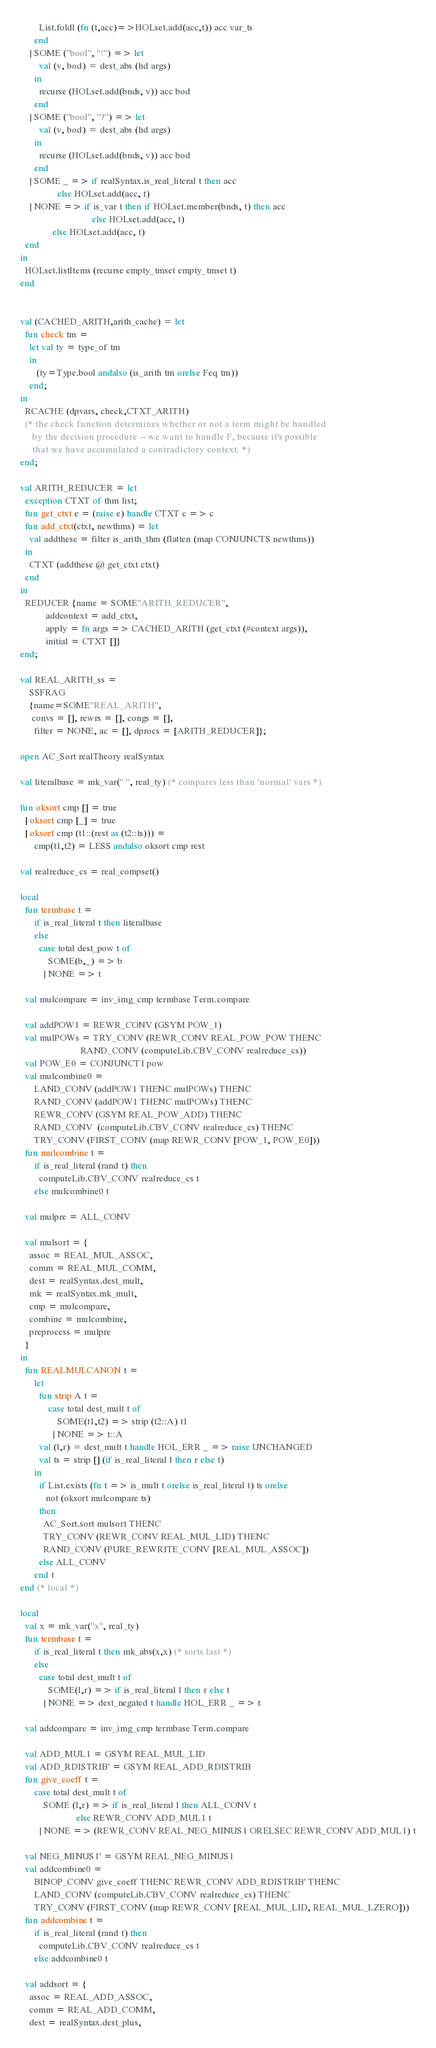<code> <loc_0><loc_0><loc_500><loc_500><_SML_>        List.foldl (fn (t,acc)=>HOLset.add(acc,t)) acc var_ts
      end
    | SOME ("bool", "!") => let
        val (v, bod) = dest_abs (hd args)
      in
        recurse (HOLset.add(bnds, v)) acc bod
      end
    | SOME ("bool", "?") => let
        val (v, bod) = dest_abs (hd args)
      in
        recurse (HOLset.add(bnds, v)) acc bod
      end
    | SOME _ => if realSyntax.is_real_literal t then acc
                else HOLset.add(acc, t)
    | NONE => if is_var t then if HOLset.member(bnds, t) then acc
                               else HOLset.add(acc, t)
              else HOLset.add(acc, t)
  end
in
  HOLset.listItems (recurse empty_tmset empty_tmset t)
end


val (CACHED_ARITH,arith_cache) = let
  fun check tm =
    let val ty = type_of tm
    in
       (ty=Type.bool andalso (is_arith tm orelse Feq tm))
    end;
in
  RCACHE (dpvars, check,CTXT_ARITH)
  (* the check function determines whether or not a term might be handled
     by the decision procedure -- we want to handle F, because it's possible
     that we have accumulated a contradictory context. *)
end;

val ARITH_REDUCER = let
  exception CTXT of thm list;
  fun get_ctxt e = (raise e) handle CTXT c => c
  fun add_ctxt(ctxt, newthms) = let
    val addthese = filter is_arith_thm (flatten (map CONJUNCTS newthms))
  in
    CTXT (addthese @ get_ctxt ctxt)
  end
in
  REDUCER {name = SOME"ARITH_REDUCER",
           addcontext = add_ctxt,
           apply = fn args => CACHED_ARITH (get_ctxt (#context args)),
           initial = CTXT []}
end;

val REAL_ARITH_ss =
    SSFRAG
    {name=SOME"REAL_ARITH",
     convs = [], rewrs = [], congs = [],
      filter = NONE, ac = [], dprocs = [ARITH_REDUCER]};

open AC_Sort realTheory realSyntax

val literalbase = mk_var(" ", real_ty) (* compares less than 'normal' vars *)

fun oksort cmp [] = true
  | oksort cmp [_] = true
  | oksort cmp (t1::(rest as (t2::ts))) =
      cmp(t1,t2) = LESS andalso oksort cmp rest

val realreduce_cs = real_compset()

local
  fun termbase t =
      if is_real_literal t then literalbase
      else
        case total dest_pow t of
            SOME(b,_) => b
          | NONE => t

  val mulcompare = inv_img_cmp termbase Term.compare

  val addPOW1 = REWR_CONV (GSYM POW_1)
  val mulPOWs = TRY_CONV (REWR_CONV REAL_POW_POW THENC
                          RAND_CONV (computeLib.CBV_CONV realreduce_cs))
  val POW_E0 = CONJUNCT1 pow
  val mulcombine0 =
      LAND_CONV (addPOW1 THENC mulPOWs) THENC
      RAND_CONV (addPOW1 THENC mulPOWs) THENC
      REWR_CONV (GSYM REAL_POW_ADD) THENC
      RAND_CONV  (computeLib.CBV_CONV realreduce_cs) THENC
      TRY_CONV (FIRST_CONV (map REWR_CONV [POW_1, POW_E0]))
  fun mulcombine t =
      if is_real_literal (rand t) then
        computeLib.CBV_CONV realreduce_cs t
      else mulcombine0 t

  val mulpre = ALL_CONV

  val mulsort = {
    assoc = REAL_MUL_ASSOC,
    comm = REAL_MUL_COMM,
    dest = realSyntax.dest_mult,
    mk = realSyntax.mk_mult,
    cmp = mulcompare,
    combine = mulcombine,
    preprocess = mulpre
  }
in
  fun REALMULCANON t =
      let
        fun strip A t =
            case total dest_mult t of
                SOME(t1,t2) => strip (t2::A) t1
              | NONE => t::A
        val (l,r) = dest_mult t handle HOL_ERR _ => raise UNCHANGED
        val ts = strip [] (if is_real_literal l then r else t)
      in
        if List.exists (fn t => is_mult t orelse is_real_literal t) ts orelse
           not (oksort mulcompare ts)
        then
          AC_Sort.sort mulsort THENC
          TRY_CONV (REWR_CONV REAL_MUL_LID) THENC
          RAND_CONV (PURE_REWRITE_CONV [REAL_MUL_ASSOC])
        else ALL_CONV
      end t
end (* local *)

local
  val x = mk_var("x", real_ty)
  fun termbase t =
      if is_real_literal t then mk_abs(x,x) (* sorts last *)
      else
        case total dest_mult t of
            SOME(l,r) => if is_real_literal l then r else t
          | NONE => dest_negated t handle HOL_ERR _ => t

  val addcompare = inv_img_cmp termbase Term.compare

  val ADD_MUL1 = GSYM REAL_MUL_LID
  val ADD_RDISTRIB' = GSYM REAL_ADD_RDISTRIB
  fun give_coeff t =
      case total dest_mult t of
          SOME (l,r) => if is_real_literal l then ALL_CONV t
                        else REWR_CONV ADD_MUL1 t
        | NONE => (REWR_CONV REAL_NEG_MINUS1 ORELSEC REWR_CONV ADD_MUL1) t

  val NEG_MINUS1' = GSYM REAL_NEG_MINUS1
  val addcombine0 =
      BINOP_CONV give_coeff THENC REWR_CONV ADD_RDISTRIB' THENC
      LAND_CONV (computeLib.CBV_CONV realreduce_cs) THENC
      TRY_CONV (FIRST_CONV (map REWR_CONV [REAL_MUL_LID, REAL_MUL_LZERO]))
  fun addcombine t =
      if is_real_literal (rand t) then
        computeLib.CBV_CONV realreduce_cs t
      else addcombine0 t

  val addsort = {
    assoc = REAL_ADD_ASSOC,
    comm = REAL_ADD_COMM,
    dest = realSyntax.dest_plus,</code> 